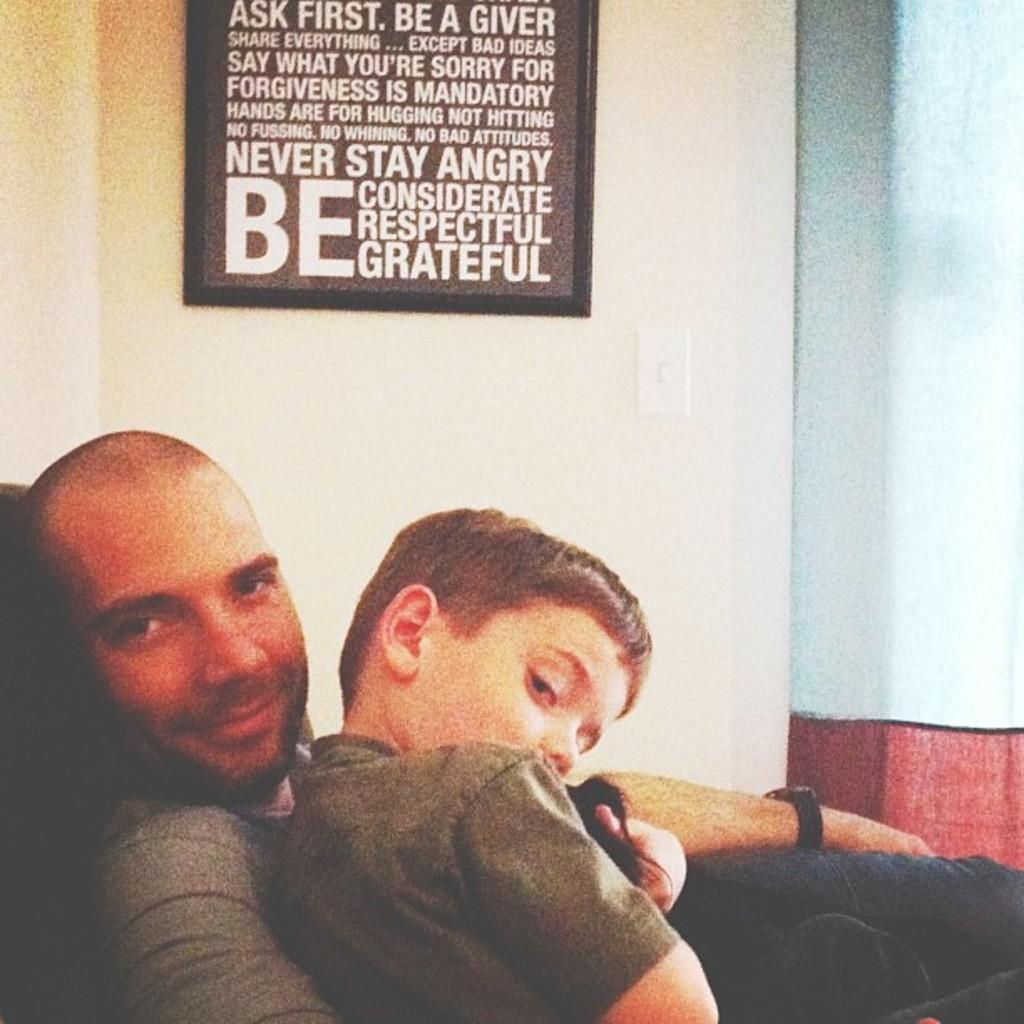Who are the people in the image? There is a man and a boy in the image. Where are the man and the boy located in the image? The man and the boy are in the center of the image. What can be seen on the wall in the background? There is a black color board on the wall in the background. What is written on the board? Something is written on the board, but we cannot determine the exact content from the image. What type of art is the man helping the boy create in the image? There is no art or indication of the man helping the boy create anything in the image. Where is the oven located in the image? There is no oven present in the image. 